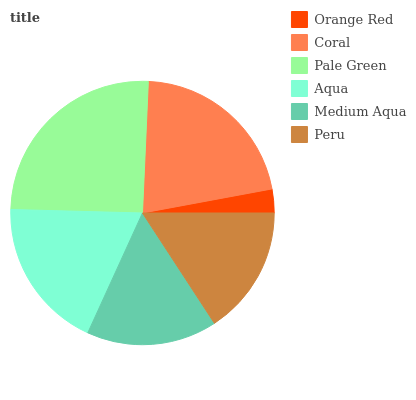Is Orange Red the minimum?
Answer yes or no. Yes. Is Pale Green the maximum?
Answer yes or no. Yes. Is Coral the minimum?
Answer yes or no. No. Is Coral the maximum?
Answer yes or no. No. Is Coral greater than Orange Red?
Answer yes or no. Yes. Is Orange Red less than Coral?
Answer yes or no. Yes. Is Orange Red greater than Coral?
Answer yes or no. No. Is Coral less than Orange Red?
Answer yes or no. No. Is Aqua the high median?
Answer yes or no. Yes. Is Medium Aqua the low median?
Answer yes or no. Yes. Is Peru the high median?
Answer yes or no. No. Is Aqua the low median?
Answer yes or no. No. 